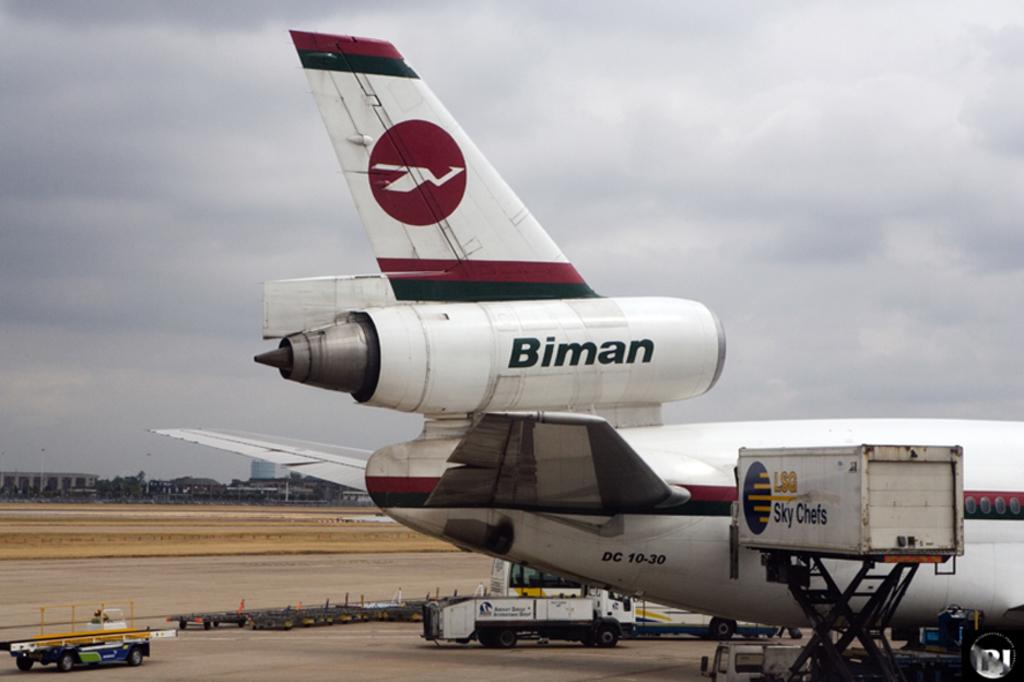<image>
Offer a succinct explanation of the picture presented. A white airplane with red and black stripes has the word Biman on its jet engine. 